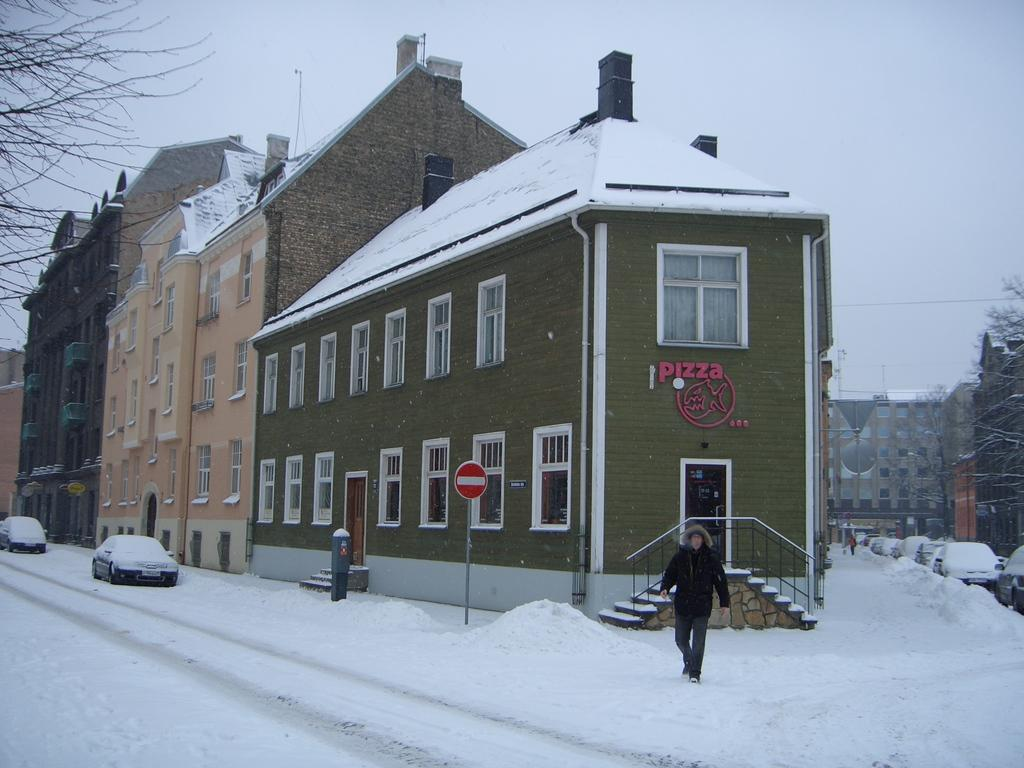What type of structures can be seen in the image? There are buildings in the image. What else can be seen in the image besides buildings? There are vehicles, windows, doors, sign boards, staircases, trees, and grills visible in the image. What is the weather like in the image? There is snow in the image, indicating a cold or wintery environment. What can be seen in the background of the image? The sky is visible in the background of the image. What type of temper does the army have in the image? There is no army present in the image, so it is not possible to determine their temper. What type of stove can be seen in the image? There is no stove present in the image. 